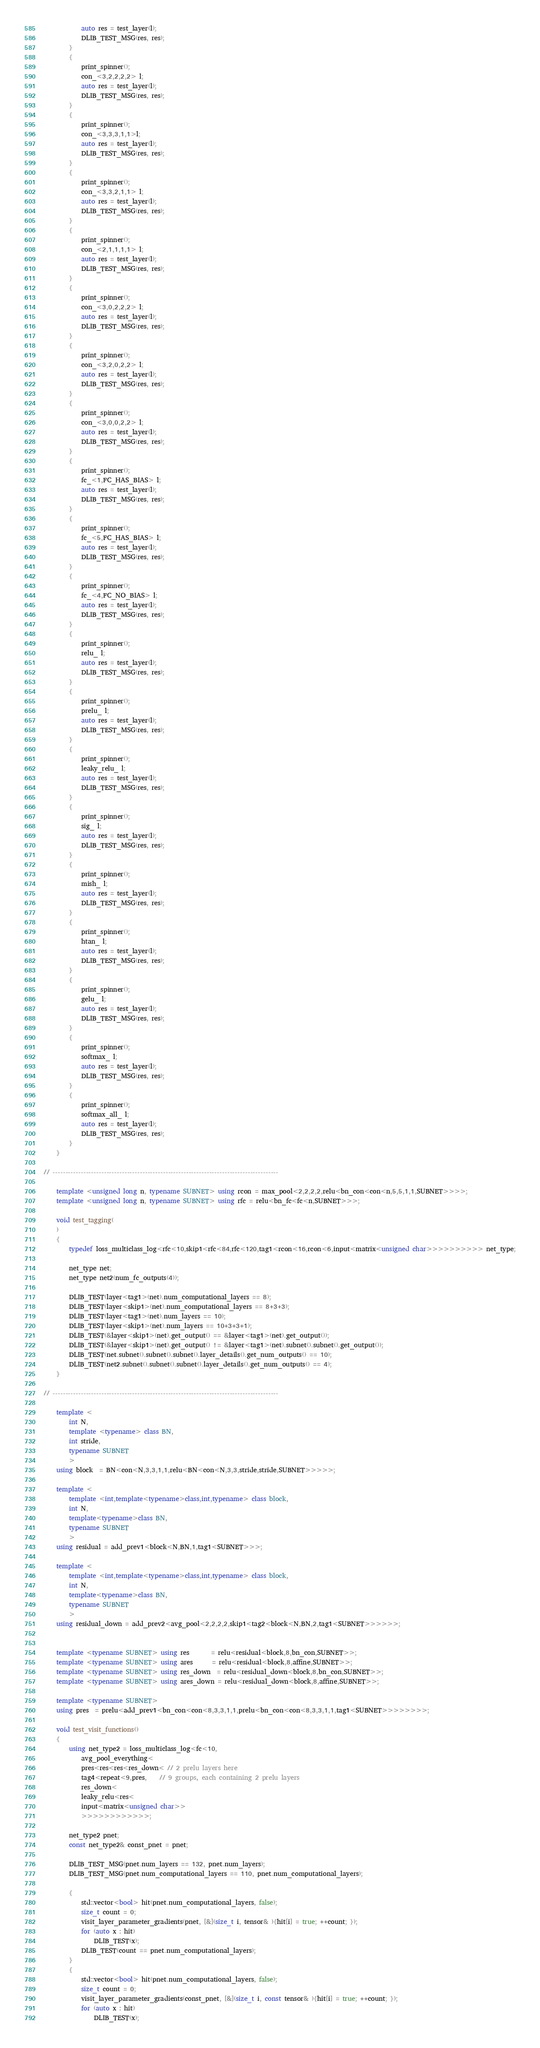Convert code to text. <code><loc_0><loc_0><loc_500><loc_500><_C++_>            auto res = test_layer(l);
            DLIB_TEST_MSG(res, res);
        }
        {
            print_spinner();
            con_<3,2,2,2,2> l;
            auto res = test_layer(l);
            DLIB_TEST_MSG(res, res);
        }
        {
            print_spinner();
            con_<3,3,3,1,1>l;
            auto res = test_layer(l);
            DLIB_TEST_MSG(res, res);
        }
        {
            print_spinner();
            con_<3,3,2,1,1> l;
            auto res = test_layer(l);
            DLIB_TEST_MSG(res, res);
        }
        {
            print_spinner();
            con_<2,1,1,1,1> l;
            auto res = test_layer(l);
            DLIB_TEST_MSG(res, res);
        }
        {
            print_spinner();
            con_<3,0,2,2,2> l;
            auto res = test_layer(l);
            DLIB_TEST_MSG(res, res);
        }
        {
            print_spinner();
            con_<3,2,0,2,2> l;
            auto res = test_layer(l);
            DLIB_TEST_MSG(res, res);
        }
        {
            print_spinner();
            con_<3,0,0,2,2> l;
            auto res = test_layer(l);
            DLIB_TEST_MSG(res, res);
        }
        {
            print_spinner();
            fc_<1,FC_HAS_BIAS> l;
            auto res = test_layer(l);
            DLIB_TEST_MSG(res, res);
        }
        {
            print_spinner();
            fc_<5,FC_HAS_BIAS> l;
            auto res = test_layer(l);
            DLIB_TEST_MSG(res, res);
        }
        {
            print_spinner();
            fc_<4,FC_NO_BIAS> l;
            auto res = test_layer(l);
            DLIB_TEST_MSG(res, res);
        }
        {
            print_spinner();
            relu_ l;
            auto res = test_layer(l);
            DLIB_TEST_MSG(res, res);
        }
        {
            print_spinner();
            prelu_ l;
            auto res = test_layer(l);
            DLIB_TEST_MSG(res, res);
        }
        {
            print_spinner();
            leaky_relu_ l;
            auto res = test_layer(l);
            DLIB_TEST_MSG(res, res);
        }
        {
            print_spinner();
            sig_ l;
            auto res = test_layer(l);
            DLIB_TEST_MSG(res, res);
        }
        {
            print_spinner();
            mish_ l;
            auto res = test_layer(l);
            DLIB_TEST_MSG(res, res);
        }
        {
            print_spinner();
            htan_ l;
            auto res = test_layer(l);
            DLIB_TEST_MSG(res, res);
        }
        {
            print_spinner();
            gelu_ l;
            auto res = test_layer(l);
            DLIB_TEST_MSG(res, res);
        }
        {
            print_spinner();
            softmax_ l;
            auto res = test_layer(l);
            DLIB_TEST_MSG(res, res);
        }
        {
            print_spinner();
            softmax_all_ l;
            auto res = test_layer(l);
            DLIB_TEST_MSG(res, res);
        }
    }

// ----------------------------------------------------------------------------------------

    template <unsigned long n, typename SUBNET> using rcon = max_pool<2,2,2,2,relu<bn_con<con<n,5,5,1,1,SUBNET>>>>;
    template <unsigned long n, typename SUBNET> using rfc = relu<bn_fc<fc<n,SUBNET>>>;

    void test_tagging(
    )
    {
        typedef loss_multiclass_log<rfc<10,skip1<rfc<84,rfc<120,tag1<rcon<16,rcon<6,input<matrix<unsigned char>>>>>>>>>> net_type;

        net_type net;
        net_type net2(num_fc_outputs(4));

        DLIB_TEST(layer<tag1>(net).num_computational_layers == 8);
        DLIB_TEST(layer<skip1>(net).num_computational_layers == 8+3+3);
        DLIB_TEST(layer<tag1>(net).num_layers == 10);
        DLIB_TEST(layer<skip1>(net).num_layers == 10+3+3+1);
        DLIB_TEST(&layer<skip1>(net).get_output() == &layer<tag1>(net).get_output());
        DLIB_TEST(&layer<skip1>(net).get_output() != &layer<tag1>(net).subnet().subnet().get_output());
        DLIB_TEST(net.subnet().subnet().subnet().layer_details().get_num_outputs() == 10);
        DLIB_TEST(net2.subnet().subnet().subnet().layer_details().get_num_outputs() == 4);
    }

// ----------------------------------------------------------------------------------------

    template <
        int N, 
        template <typename> class BN, 
        int stride, 
        typename SUBNET
        > 
    using block  = BN<con<N,3,3,1,1,relu<BN<con<N,3,3,stride,stride,SUBNET>>>>>;

    template <
        template <int,template<typename>class,int,typename> class block, 
        int N, 
        template<typename>class BN, 
        typename SUBNET
        >
    using residual = add_prev1<block<N,BN,1,tag1<SUBNET>>>;

    template <
        template <int,template<typename>class,int,typename> class block, 
        int N, 
        template<typename>class BN, 
        typename SUBNET
        >
    using residual_down = add_prev2<avg_pool<2,2,2,2,skip1<tag2<block<N,BN,2,tag1<SUBNET>>>>>>;


    template <typename SUBNET> using res       = relu<residual<block,8,bn_con,SUBNET>>;
    template <typename SUBNET> using ares      = relu<residual<block,8,affine,SUBNET>>;
    template <typename SUBNET> using res_down  = relu<residual_down<block,8,bn_con,SUBNET>>;
    template <typename SUBNET> using ares_down = relu<residual_down<block,8,affine,SUBNET>>;

    template <typename SUBNET> 
    using pres  = prelu<add_prev1<bn_con<con<8,3,3,1,1,prelu<bn_con<con<8,3,3,1,1,tag1<SUBNET>>>>>>>>;

    void test_visit_functions()
    {
        using net_type2 = loss_multiclass_log<fc<10,
            avg_pool_everything<
            pres<res<res<res_down< // 2 prelu layers here
            tag4<repeat<9,pres,    // 9 groups, each containing 2 prelu layers  
            res_down<
            leaky_relu<res<
            input<matrix<unsigned char>>
            >>>>>>>>>>>>;

        net_type2 pnet;
        const net_type2& const_pnet = pnet;

        DLIB_TEST_MSG(pnet.num_layers == 132, pnet.num_layers);
        DLIB_TEST_MSG(pnet.num_computational_layers == 110, pnet.num_computational_layers);

        {
            std::vector<bool> hit(pnet.num_computational_layers, false);
            size_t count = 0;
            visit_layer_parameter_gradients(pnet, [&](size_t i, tensor& ){hit[i] = true; ++count; });
            for (auto x : hit)
                DLIB_TEST(x);
            DLIB_TEST(count == pnet.num_computational_layers);
        }
        {
            std::vector<bool> hit(pnet.num_computational_layers, false);
            size_t count = 0;
            visit_layer_parameter_gradients(const_pnet, [&](size_t i, const tensor& ){hit[i] = true; ++count; });
            for (auto x : hit)
                DLIB_TEST(x);</code> 